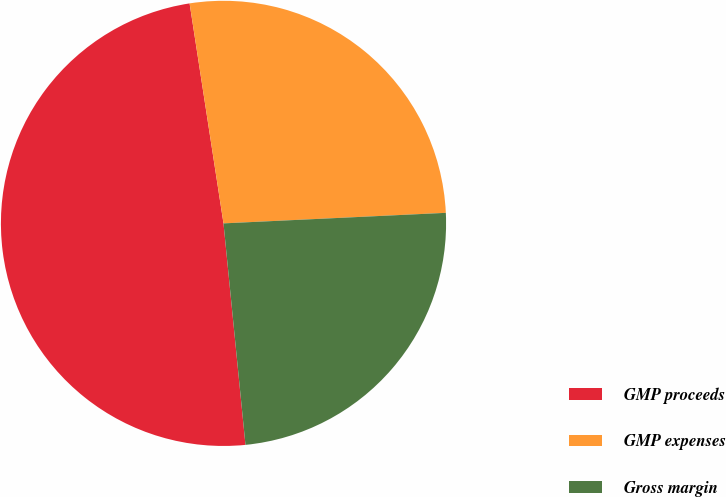Convert chart to OTSL. <chart><loc_0><loc_0><loc_500><loc_500><pie_chart><fcel>GMP proceeds<fcel>GMP expenses<fcel>Gross margin<nl><fcel>49.14%<fcel>26.68%<fcel>24.18%<nl></chart> 